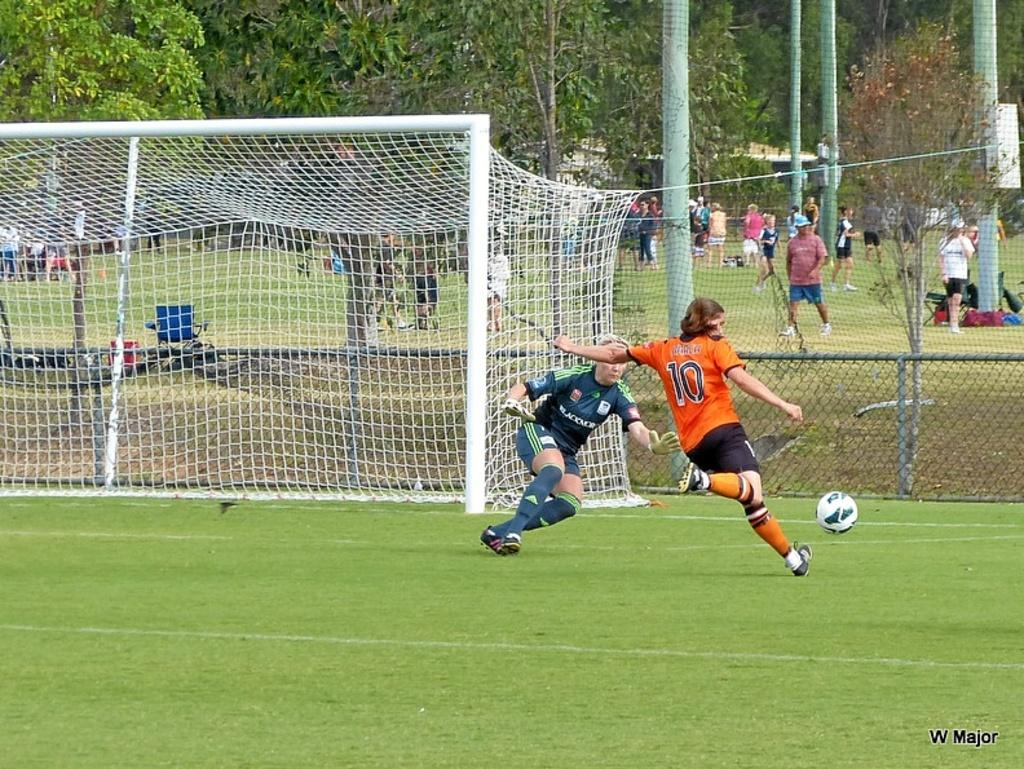<image>
Create a compact narrative representing the image presented. W major wrote on the bottom left of a soccer picture 